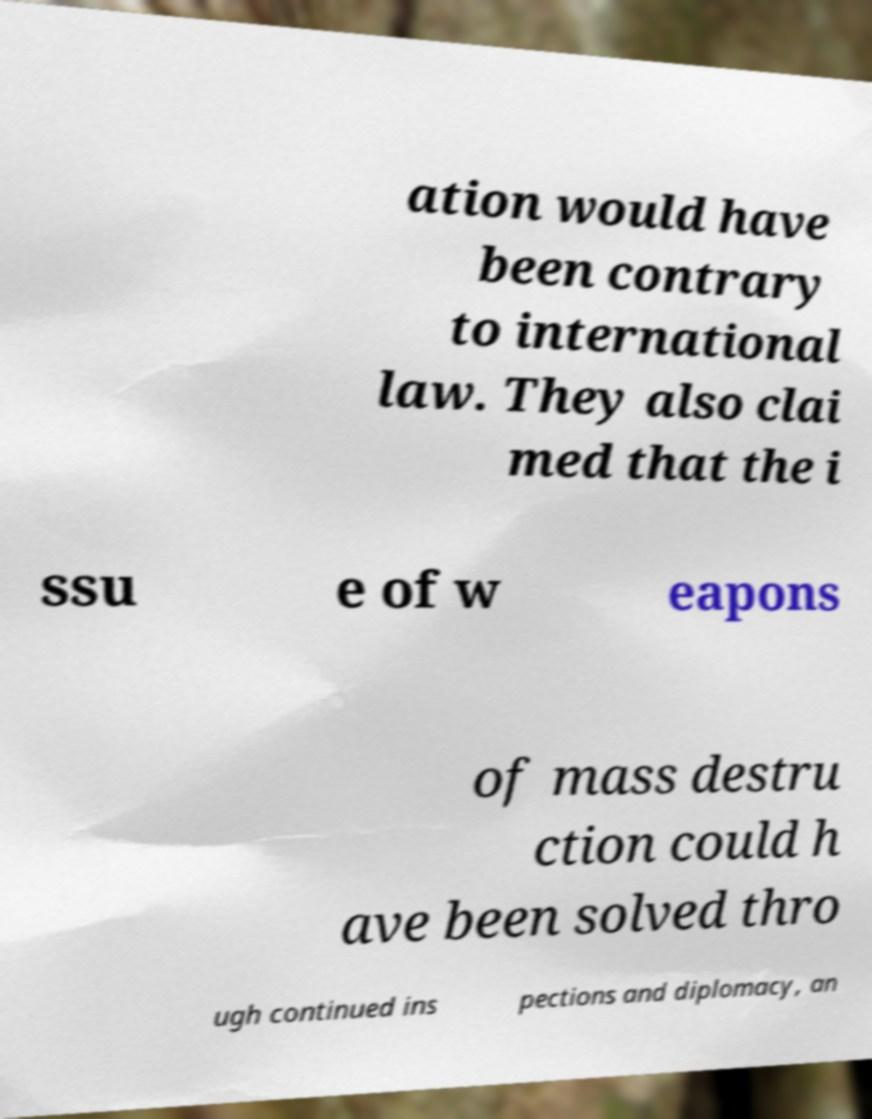Please read and relay the text visible in this image. What does it say? ation would have been contrary to international law. They also clai med that the i ssu e of w eapons of mass destru ction could h ave been solved thro ugh continued ins pections and diplomacy, an 